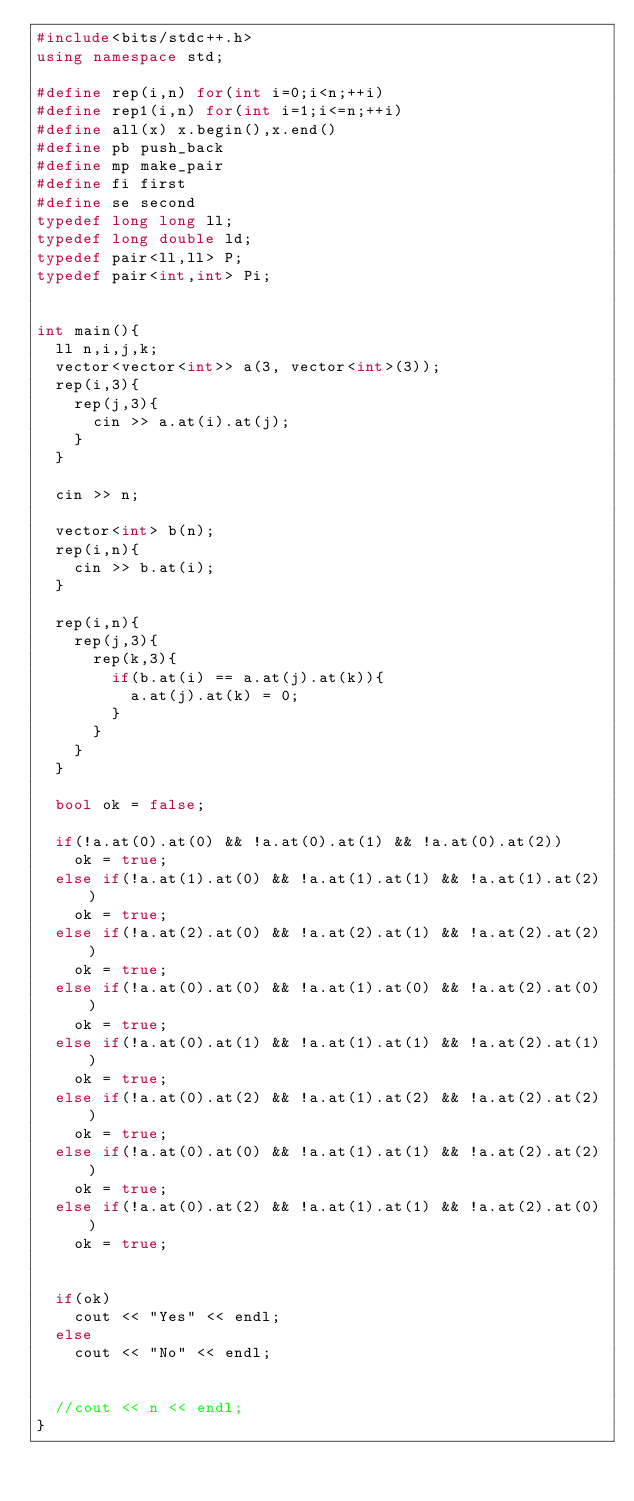Convert code to text. <code><loc_0><loc_0><loc_500><loc_500><_C++_>#include<bits/stdc++.h>
using namespace std;

#define rep(i,n) for(int i=0;i<n;++i)
#define rep1(i,n) for(int i=1;i<=n;++i)
#define all(x) x.begin(),x.end()
#define pb push_back
#define mp make_pair
#define fi first
#define se second
typedef long long ll;
typedef long double ld;
typedef pair<ll,ll> P;
typedef pair<int,int> Pi;


int main(){
  ll n,i,j,k;
  vector<vector<int>> a(3, vector<int>(3));
  rep(i,3){
    rep(j,3){
      cin >> a.at(i).at(j);
    }
  }
  
  cin >> n;
  
  vector<int> b(n);
  rep(i,n){
    cin >> b.at(i);
  }
  
  rep(i,n){
    rep(j,3){
      rep(k,3){
        if(b.at(i) == a.at(j).at(k)){
          a.at(j).at(k) = 0;
        }
      }
    }
  }
  
  bool ok = false;
  
  if(!a.at(0).at(0) && !a.at(0).at(1) && !a.at(0).at(2))
    ok = true;
  else if(!a.at(1).at(0) && !a.at(1).at(1) && !a.at(1).at(2))
    ok = true;
  else if(!a.at(2).at(0) && !a.at(2).at(1) && !a.at(2).at(2))
    ok = true;
  else if(!a.at(0).at(0) && !a.at(1).at(0) && !a.at(2).at(0))
    ok = true;
  else if(!a.at(0).at(1) && !a.at(1).at(1) && !a.at(2).at(1))
    ok = true;
  else if(!a.at(0).at(2) && !a.at(1).at(2) && !a.at(2).at(2))
    ok = true;
  else if(!a.at(0).at(0) && !a.at(1).at(1) && !a.at(2).at(2))
    ok = true;
  else if(!a.at(0).at(2) && !a.at(1).at(1) && !a.at(2).at(0))
    ok = true;
  
  
  if(ok)
    cout << "Yes" << endl;
  else
    cout << "No" << endl;
  
  
  //cout << n << endl;
}


</code> 